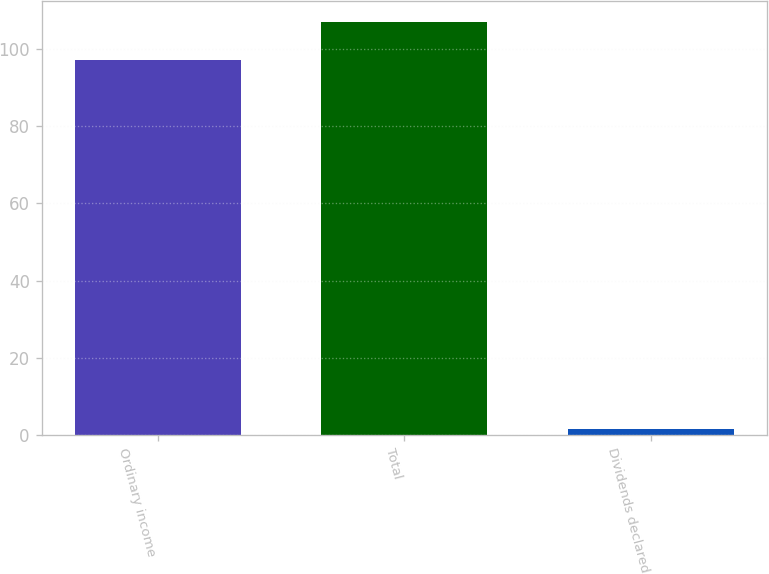Convert chart. <chart><loc_0><loc_0><loc_500><loc_500><bar_chart><fcel>Ordinary income<fcel>Total<fcel>Dividends declared<nl><fcel>97.2<fcel>107.04<fcel>1.61<nl></chart> 